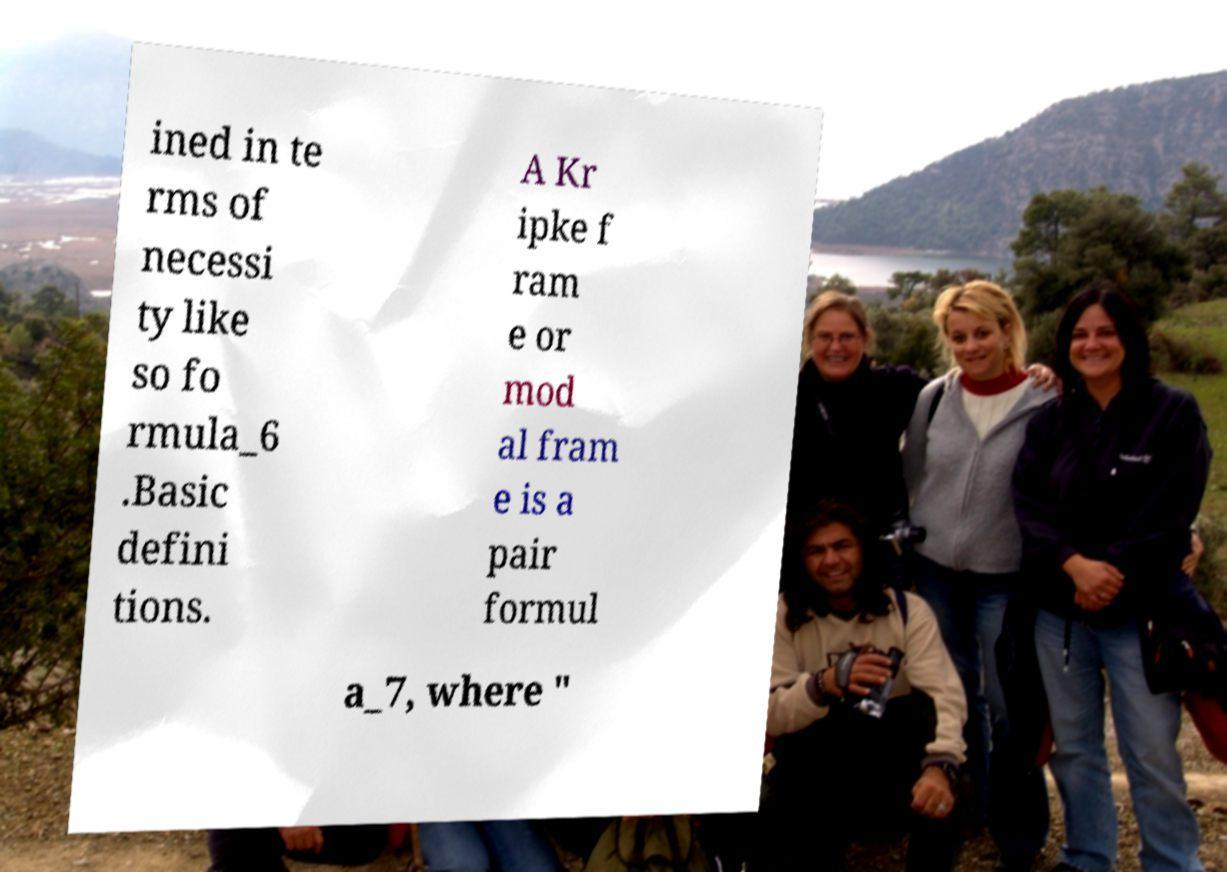What messages or text are displayed in this image? I need them in a readable, typed format. ined in te rms of necessi ty like so fo rmula_6 .Basic defini tions. A Kr ipke f ram e or mod al fram e is a pair formul a_7, where " 